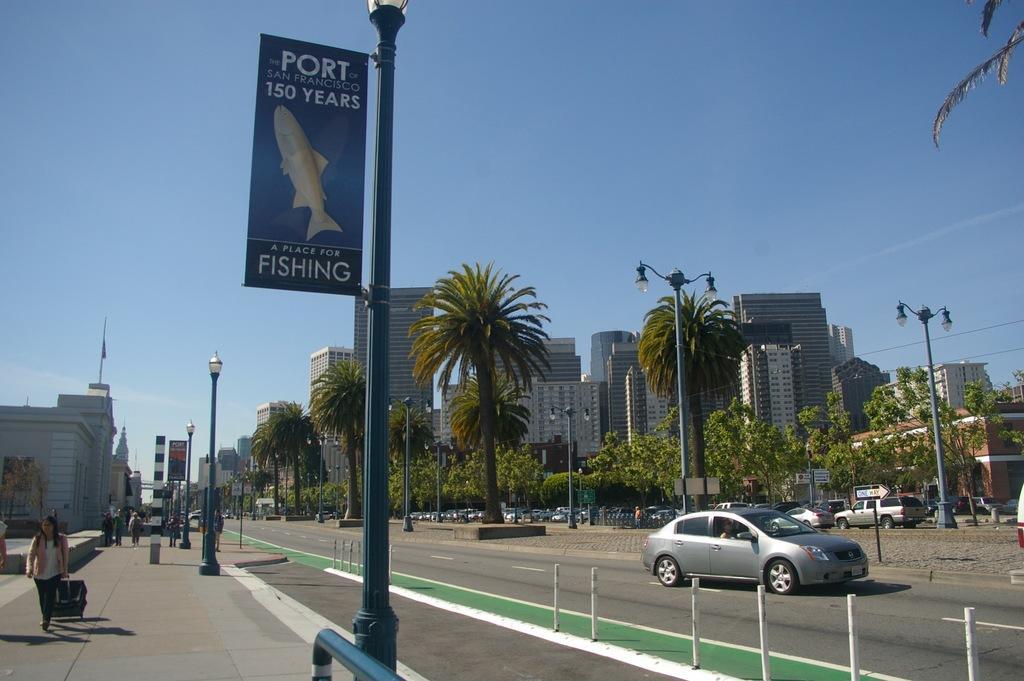Could you give a brief overview of what you see in this image? In this image I can see the road, few white colored poles and few green colored poles with few boards to them. I can see the sidewalk, few persons on the sidewalk, few vehicles on the road, few trees and few buildings. In the background I can see the sky 